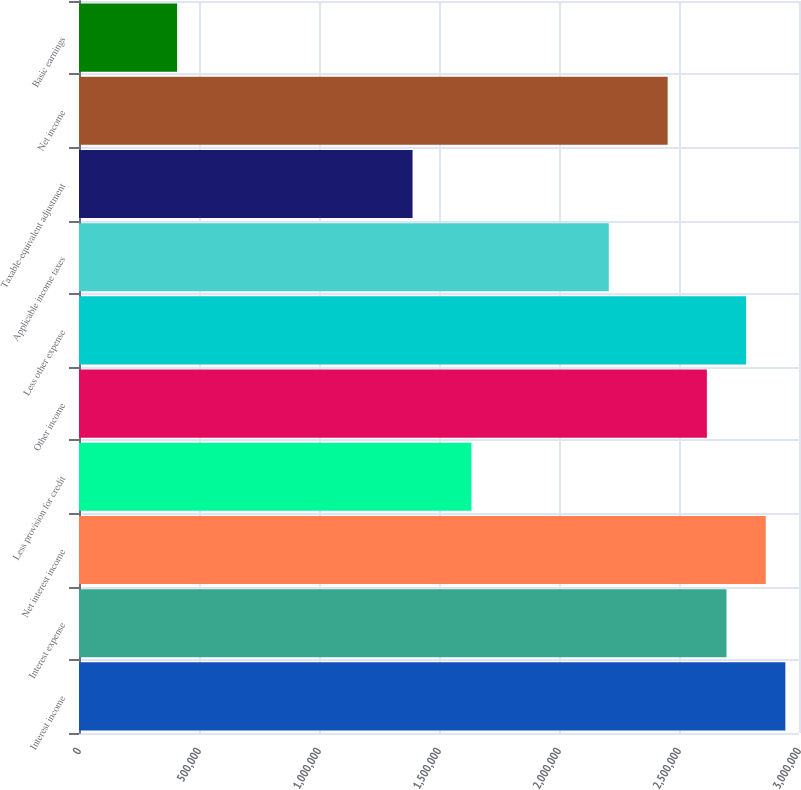Convert chart. <chart><loc_0><loc_0><loc_500><loc_500><bar_chart><fcel>Interest income<fcel>Interest expense<fcel>Net interest income<fcel>Less provision for credit<fcel>Other income<fcel>Less other expense<fcel>Applicable income taxes<fcel>Taxable-equivalent adjustment<fcel>Net income<fcel>Basic earnings<nl><fcel>2.94319e+06<fcel>2.69792e+06<fcel>2.86143e+06<fcel>1.6351e+06<fcel>2.61617e+06<fcel>2.77968e+06<fcel>2.20739e+06<fcel>1.38984e+06<fcel>2.45266e+06<fcel>408776<nl></chart> 